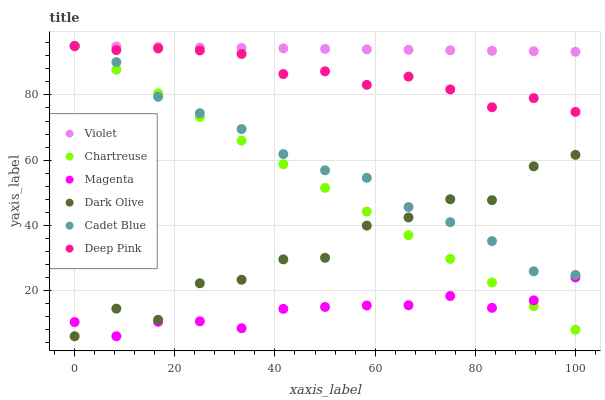Does Magenta have the minimum area under the curve?
Answer yes or no. Yes. Does Violet have the maximum area under the curve?
Answer yes or no. Yes. Does Dark Olive have the minimum area under the curve?
Answer yes or no. No. Does Dark Olive have the maximum area under the curve?
Answer yes or no. No. Is Chartreuse the smoothest?
Answer yes or no. Yes. Is Dark Olive the roughest?
Answer yes or no. Yes. Is Dark Olive the smoothest?
Answer yes or no. No. Is Chartreuse the roughest?
Answer yes or no. No. Does Dark Olive have the lowest value?
Answer yes or no. Yes. Does Chartreuse have the lowest value?
Answer yes or no. No. Does Violet have the highest value?
Answer yes or no. Yes. Does Dark Olive have the highest value?
Answer yes or no. No. Is Magenta less than Cadet Blue?
Answer yes or no. Yes. Is Violet greater than Magenta?
Answer yes or no. Yes. Does Cadet Blue intersect Dark Olive?
Answer yes or no. Yes. Is Cadet Blue less than Dark Olive?
Answer yes or no. No. Is Cadet Blue greater than Dark Olive?
Answer yes or no. No. Does Magenta intersect Cadet Blue?
Answer yes or no. No. 